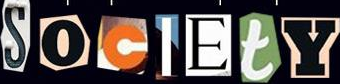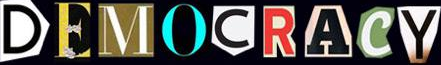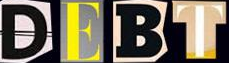Read the text from these images in sequence, separated by a semicolon. SocIEtY; DEMOCRACY; DEBT 